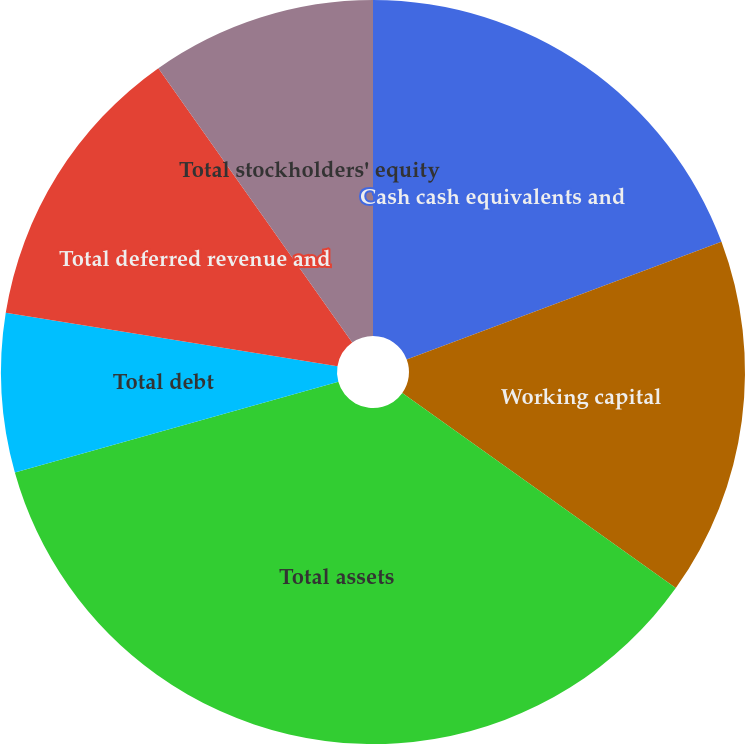<chart> <loc_0><loc_0><loc_500><loc_500><pie_chart><fcel>Cash cash equivalents and<fcel>Working capital<fcel>Total assets<fcel>Total debt<fcel>Total deferred revenue and<fcel>Total stockholders' equity<nl><fcel>19.31%<fcel>15.56%<fcel>35.78%<fcel>6.9%<fcel>12.67%<fcel>9.79%<nl></chart> 